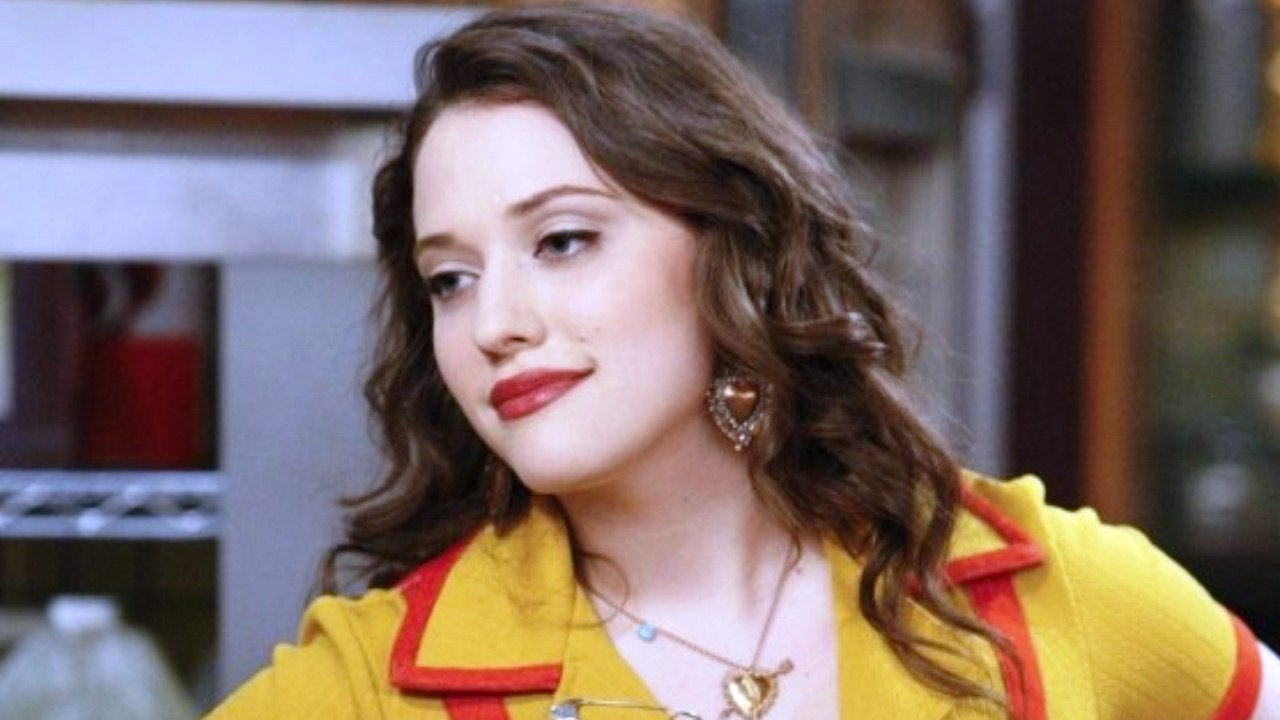Can you tell me more about the style of the cardigan and what it suggests about the character's personality? The vibrant yellow cardigan with a contrasting red collar suggests a bold, energetic personality. The color choice emits a sense of cheerfulness and creativity, indicating that the character may be outgoing and spirited. The style is casual yet fashionable, which often represents a character who is approachable and relatable, perhaps with a youthful, modern flair. 